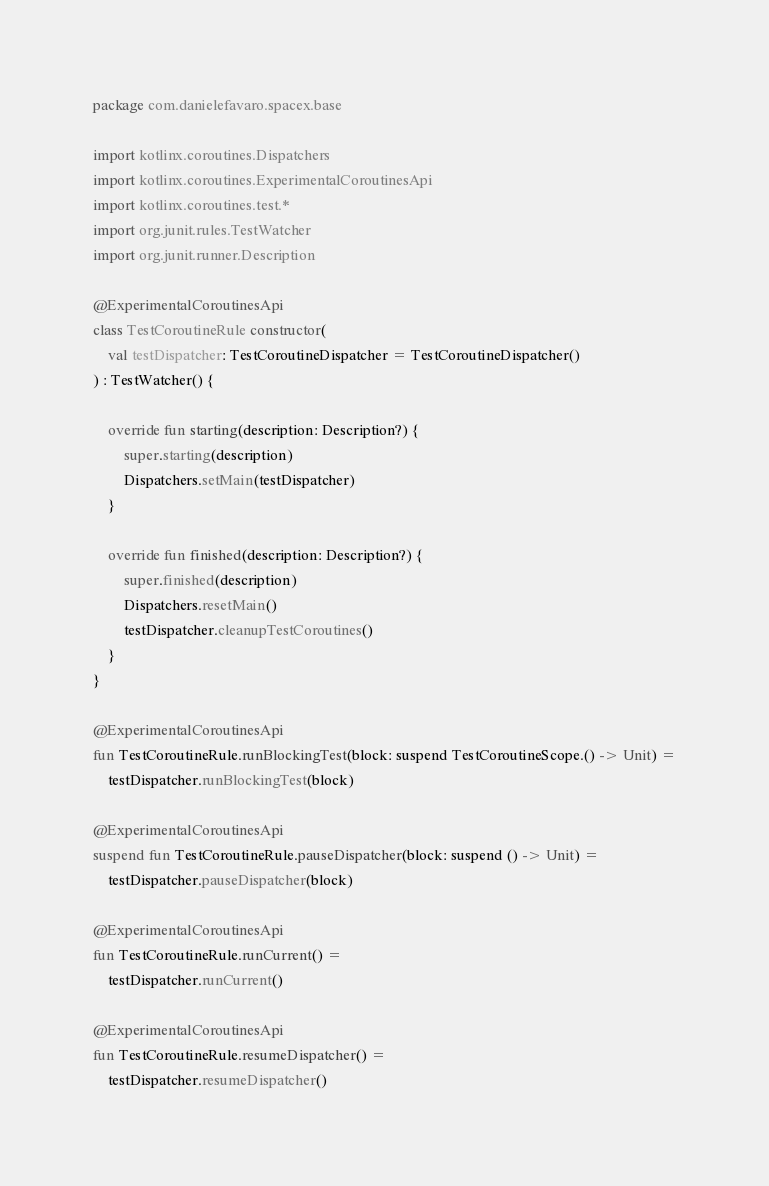<code> <loc_0><loc_0><loc_500><loc_500><_Kotlin_>package com.danielefavaro.spacex.base

import kotlinx.coroutines.Dispatchers
import kotlinx.coroutines.ExperimentalCoroutinesApi
import kotlinx.coroutines.test.*
import org.junit.rules.TestWatcher
import org.junit.runner.Description

@ExperimentalCoroutinesApi
class TestCoroutineRule constructor(
    val testDispatcher: TestCoroutineDispatcher = TestCoroutineDispatcher()
) : TestWatcher() {

    override fun starting(description: Description?) {
        super.starting(description)
        Dispatchers.setMain(testDispatcher)
    }

    override fun finished(description: Description?) {
        super.finished(description)
        Dispatchers.resetMain()
        testDispatcher.cleanupTestCoroutines()
    }
}

@ExperimentalCoroutinesApi
fun TestCoroutineRule.runBlockingTest(block: suspend TestCoroutineScope.() -> Unit) =
    testDispatcher.runBlockingTest(block)

@ExperimentalCoroutinesApi
suspend fun TestCoroutineRule.pauseDispatcher(block: suspend () -> Unit) =
    testDispatcher.pauseDispatcher(block)

@ExperimentalCoroutinesApi
fun TestCoroutineRule.runCurrent() =
    testDispatcher.runCurrent()

@ExperimentalCoroutinesApi
fun TestCoroutineRule.resumeDispatcher() =
    testDispatcher.resumeDispatcher()</code> 